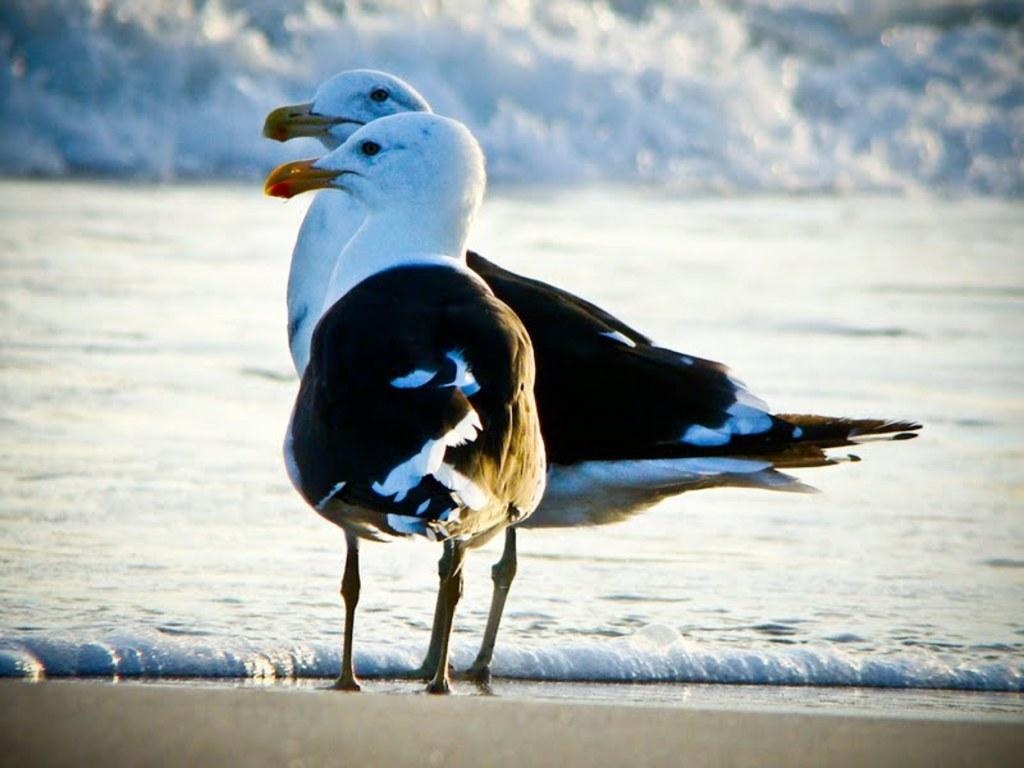What type of bird is in the image? There is a Great black-backed gull in the image. What is the gull doing in the image? The gull is standing in the image. What is in front of the gull? There is water in front of the gull. What type of farmer is visible in the image? There is no farmer present in the image; it features a Great black-backed gull standing near water. What is the gull's stomach doing in the image? The gull's stomach is not visible in the image, and therefore its actions cannot be observed. 